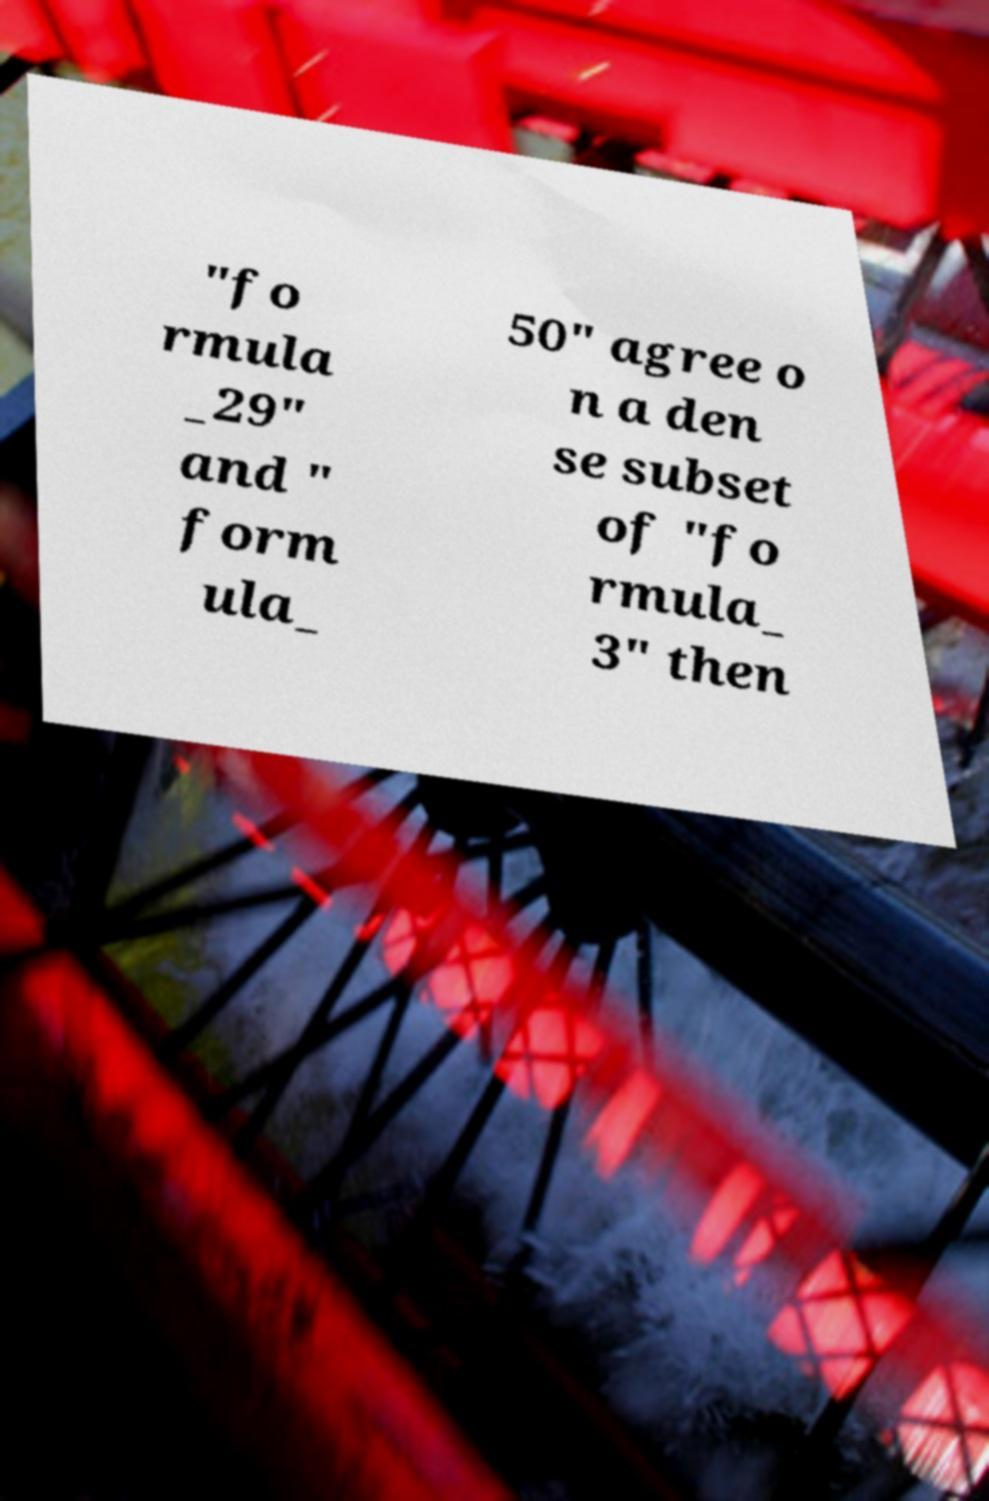What messages or text are displayed in this image? I need them in a readable, typed format. "fo rmula _29" and " form ula_ 50" agree o n a den se subset of "fo rmula_ 3" then 